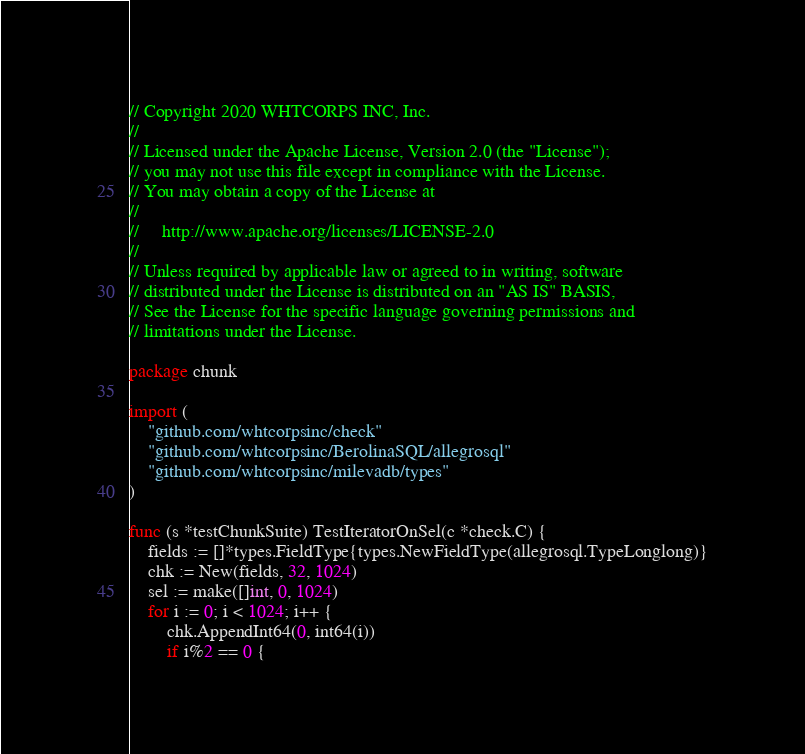Convert code to text. <code><loc_0><loc_0><loc_500><loc_500><_Go_>// Copyright 2020 WHTCORPS INC, Inc.
//
// Licensed under the Apache License, Version 2.0 (the "License");
// you may not use this file except in compliance with the License.
// You may obtain a copy of the License at
//
//     http://www.apache.org/licenses/LICENSE-2.0
//
// Unless required by applicable law or agreed to in writing, software
// distributed under the License is distributed on an "AS IS" BASIS,
// See the License for the specific language governing permissions and
// limitations under the License.

package chunk

import (
	"github.com/whtcorpsinc/check"
	"github.com/whtcorpsinc/BerolinaSQL/allegrosql"
	"github.com/whtcorpsinc/milevadb/types"
)

func (s *testChunkSuite) TestIteratorOnSel(c *check.C) {
	fields := []*types.FieldType{types.NewFieldType(allegrosql.TypeLonglong)}
	chk := New(fields, 32, 1024)
	sel := make([]int, 0, 1024)
	for i := 0; i < 1024; i++ {
		chk.AppendInt64(0, int64(i))
		if i%2 == 0 {</code> 